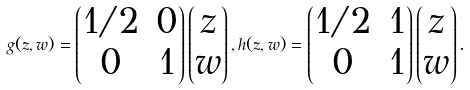<formula> <loc_0><loc_0><loc_500><loc_500>g ( z , w ) = \begin{pmatrix} 1 / 2 & 0 \\ 0 & 1 \end{pmatrix} \begin{pmatrix} z \\ w \end{pmatrix} , h ( z , w ) = \begin{pmatrix} 1 / 2 & 1 \\ 0 & 1 \end{pmatrix} \begin{pmatrix} z \\ w \end{pmatrix} .</formula> 